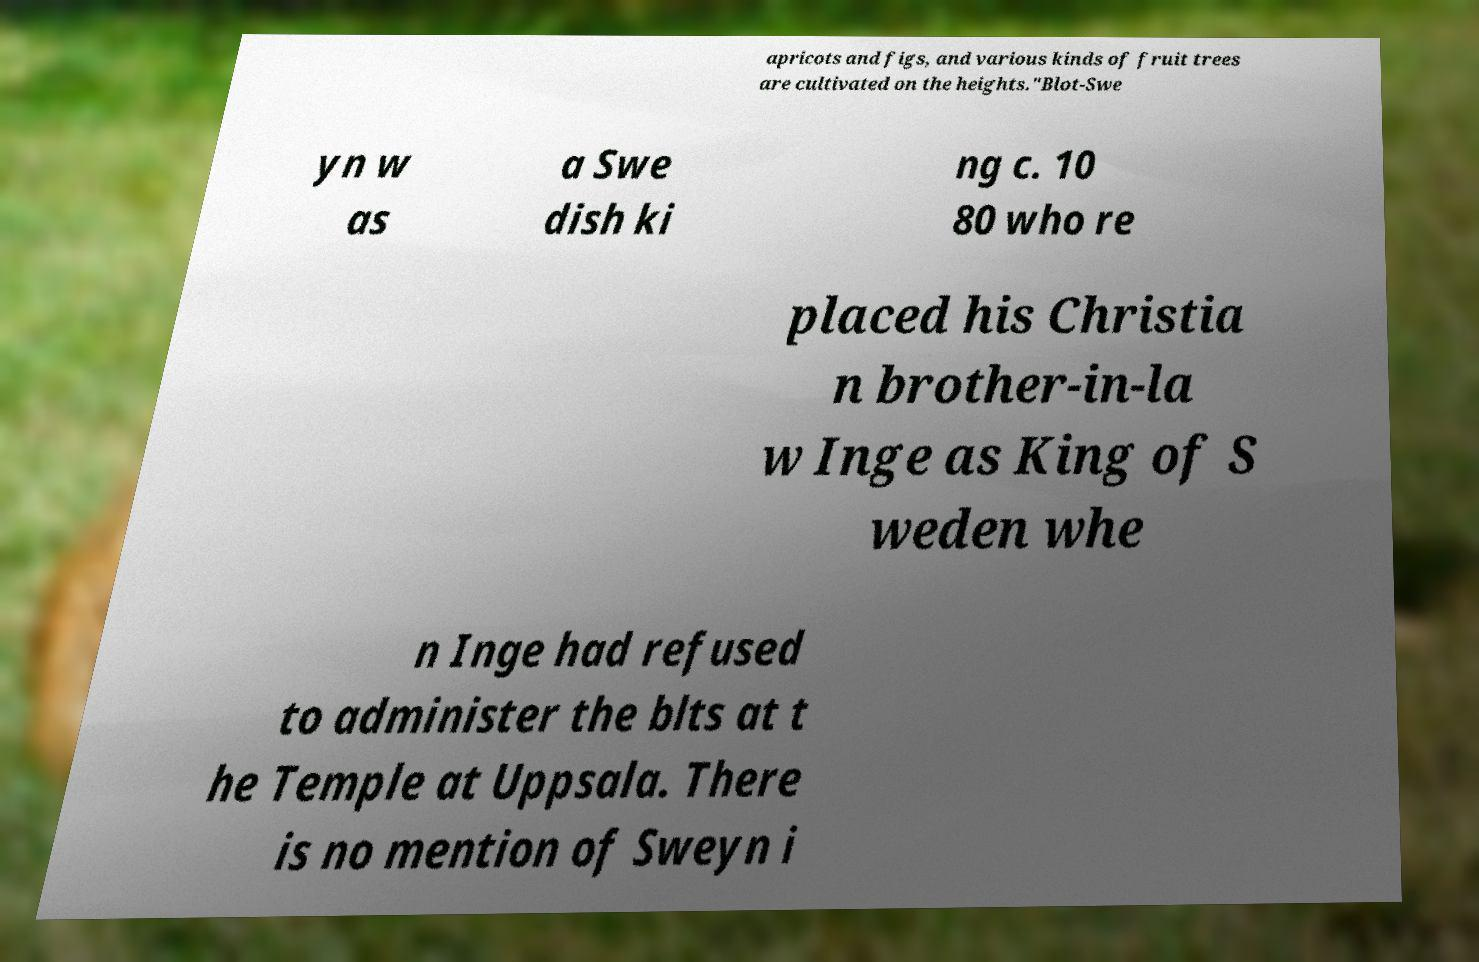There's text embedded in this image that I need extracted. Can you transcribe it verbatim? apricots and figs, and various kinds of fruit trees are cultivated on the heights."Blot-Swe yn w as a Swe dish ki ng c. 10 80 who re placed his Christia n brother-in-la w Inge as King of S weden whe n Inge had refused to administer the blts at t he Temple at Uppsala. There is no mention of Sweyn i 